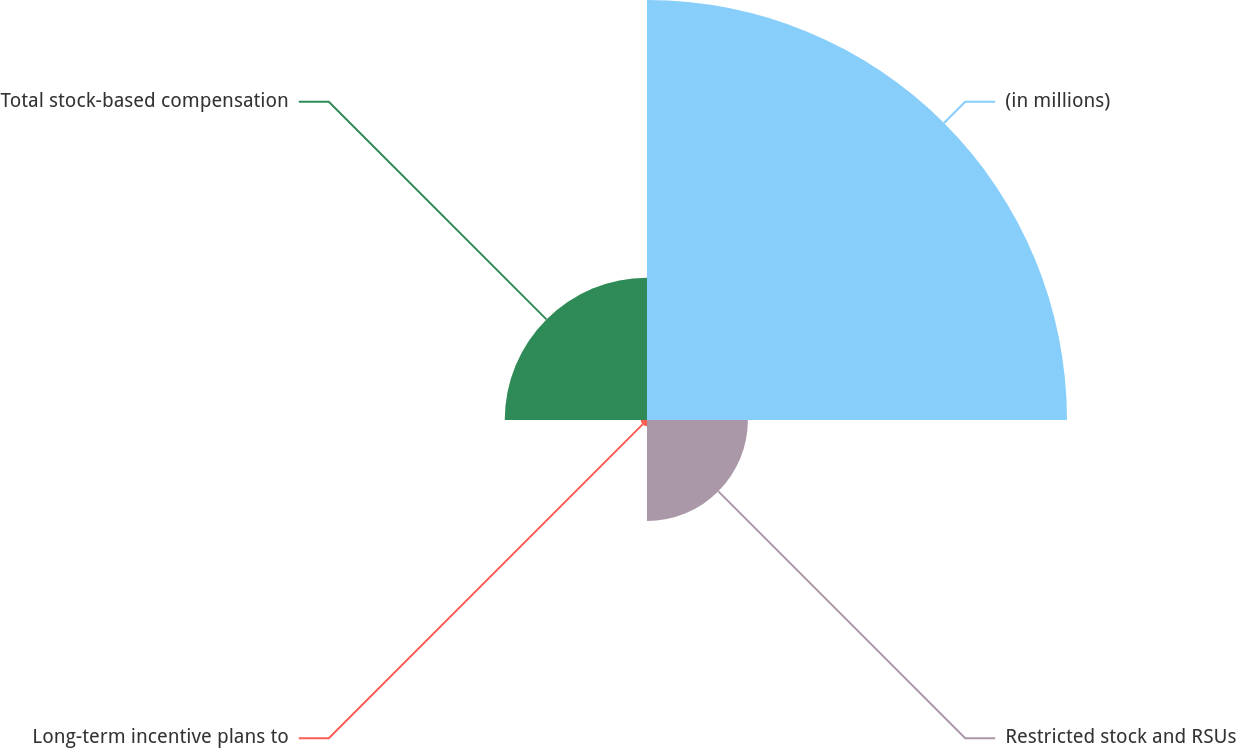<chart> <loc_0><loc_0><loc_500><loc_500><pie_chart><fcel>(in millions)<fcel>Restricted stock and RSUs<fcel>Long-term incentive plans to<fcel>Total stock-based compensation<nl><fcel>62.74%<fcel>15.07%<fcel>0.93%<fcel>21.25%<nl></chart> 